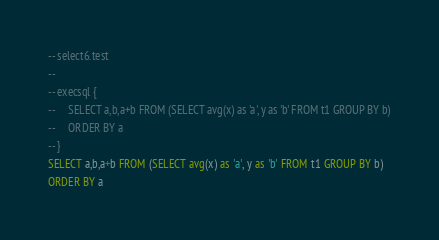Convert code to text. <code><loc_0><loc_0><loc_500><loc_500><_SQL_>-- select6.test
-- 
-- execsql {
--     SELECT a,b,a+b FROM (SELECT avg(x) as 'a', y as 'b' FROM t1 GROUP BY b)
--     ORDER BY a
-- }
SELECT a,b,a+b FROM (SELECT avg(x) as 'a', y as 'b' FROM t1 GROUP BY b)
ORDER BY a</code> 